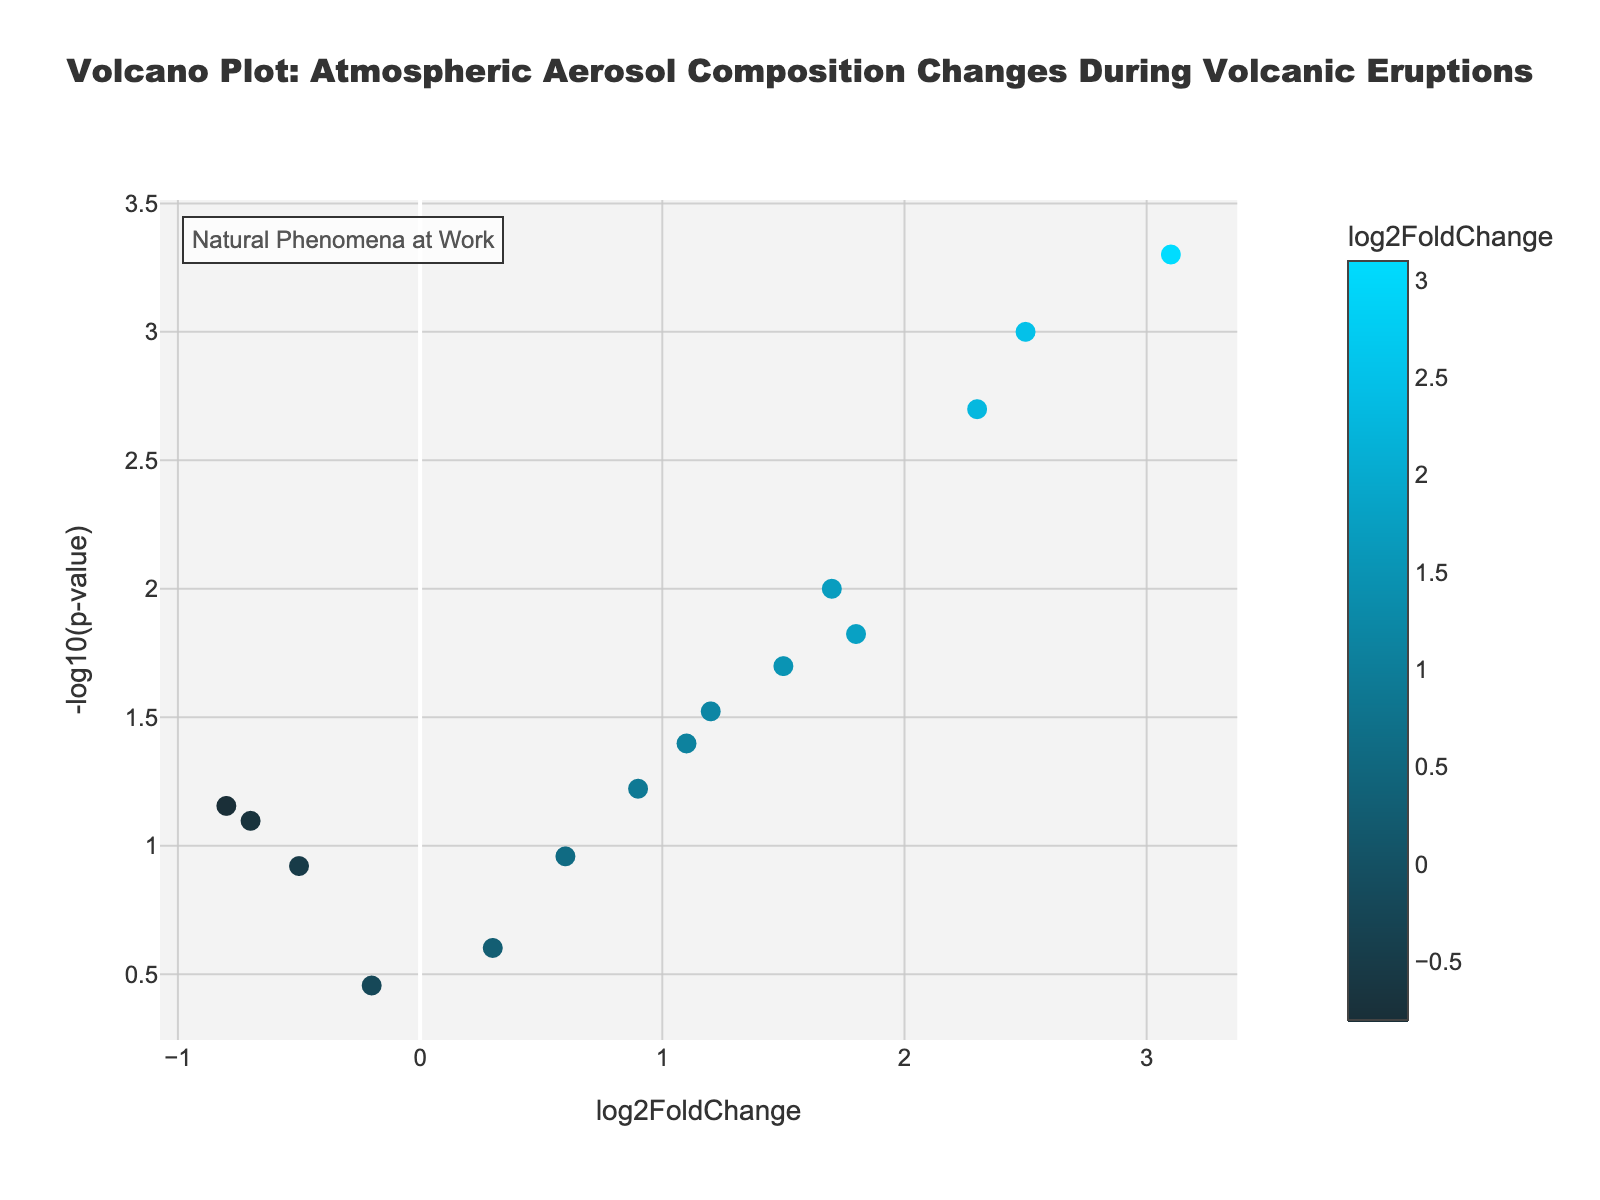How many data points are displayed in the plot? Counting the number of data points in the plot, there are 15 individual markers representing each element of the atmospheric aerosol composition.
Answer: 15 What is the title of the plot? The title of the plot is located at the top and reads "Volcano Plot: Atmospheric Aerosol Composition Changes During Volcanic Eruptions."
Answer: Volcano Plot: Atmospheric Aerosol Composition Changes During Volcanic Eruptions Which axis represents log2FoldChange? The x-axis title, located below the horizontal axis in the plot, indicates that log2FoldChange is represented on the x-axis.
Answer: x-axis Which compound has the highest -log10(p-value)? By looking at the vertical position of the data points, the highest -log10(p-value) corresponds to Hydrogen sulfide, positioned at the topmost part of the plot.
Answer: Hydrogen sulfide What is the color scale used in the plot? The plot uses a gradient color scale that progresses from dark blue to light blue to represent the log2FoldChange values.
Answer: Gradient from dark blue to light blue What's the average log2FoldChange of Sulfur dioxide and Hydrofluoric acid? Sulfur dioxide has a log2FoldChange of 2.5, and Hydrofluoric acid has a log2FoldChange of 2.3. The average is calculated as (2.5 + 2.3) / 2 = 2.4.
Answer: 2.4 Which compound has a log2FoldChange greater than 2 and the smallest p-value? Hydrogen sulfide has a log2FoldChange of 3.1 and the smallest p-value of 0.0005 among the compounds with a log2FoldChange greater than 2.
Answer: Hydrogen sulfide What is the log2FoldChange of Ammonia? By locating the data point labeled Ammonia, the log2FoldChange value on the x-axis is approximately 1.7.
Answer: 1.7 Which data point shows a decrease in abundance with a significant p-value (less than 0.05)? Water vapor has a negative log2FoldChange of -0.7 and a p-value of 0.08, which is not less than 0.05. Oxygen has a -0.8 log2FoldChange and a p-value of 0.07, also not less than 0.05. Therefore, no data point meets this criterion.
Answer: None Identify the data point with the smallest -log10(p-value)? The marker placed at the smallest -log10(p-value) on the y-axis corresponds to Argon, with -log10(p-value) around 0.45.
Answer: Argon 